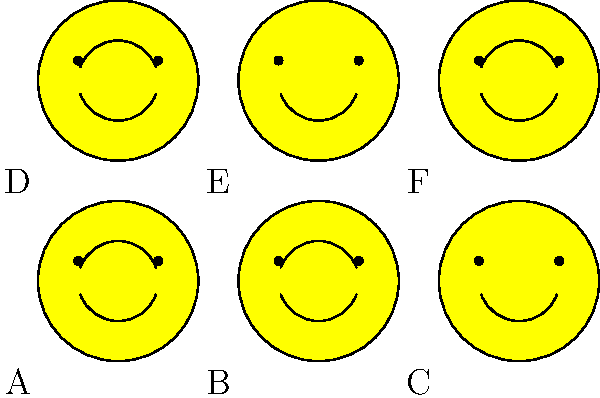In the cartoon scenarios above, which situation depicts the highest level of empathy between the characters? Consider the emotional expressions and potential social interactions represented. To determine the highest level of empathy, we need to analyze each scenario:

1. Scenario A: Both faces are smiling, indicating a positive interaction.
2. Scenario B: Similar to A, both faces are smiling.
3. Scenario C: One face is smiling while the other is frowning, suggesting a potential conflict or misunderstanding.
4. Scenario D: Both faces are smiling, similar to A and B.
5. Scenario E: One face is smiling while the other is frowning, similar to C.
6. Scenario F: Both faces are smiling, similar to A, B, and D.

Empathy involves understanding and sharing the feelings of another. The scenarios where both faces are smiling (A, B, D, and F) suggest a mutual positive emotional state, which could indicate empathy.

However, true empathy often involves responding to someone else's emotions, particularly when they are different from our own. In this context, scenarios C and E present opportunities for empathy, as one character could potentially respond to the other's negative emotion.

Among C and E, scenario E shows a more empathetic response. The smiling face in E could be interpreted as a supportive reaction to the frowning face, indicating an attempt to understand and uplift the other's emotional state.

Therefore, scenario E represents the highest potential for empathy, as it depicts a possible supportive response to another's negative emotion.
Answer: Scenario E 